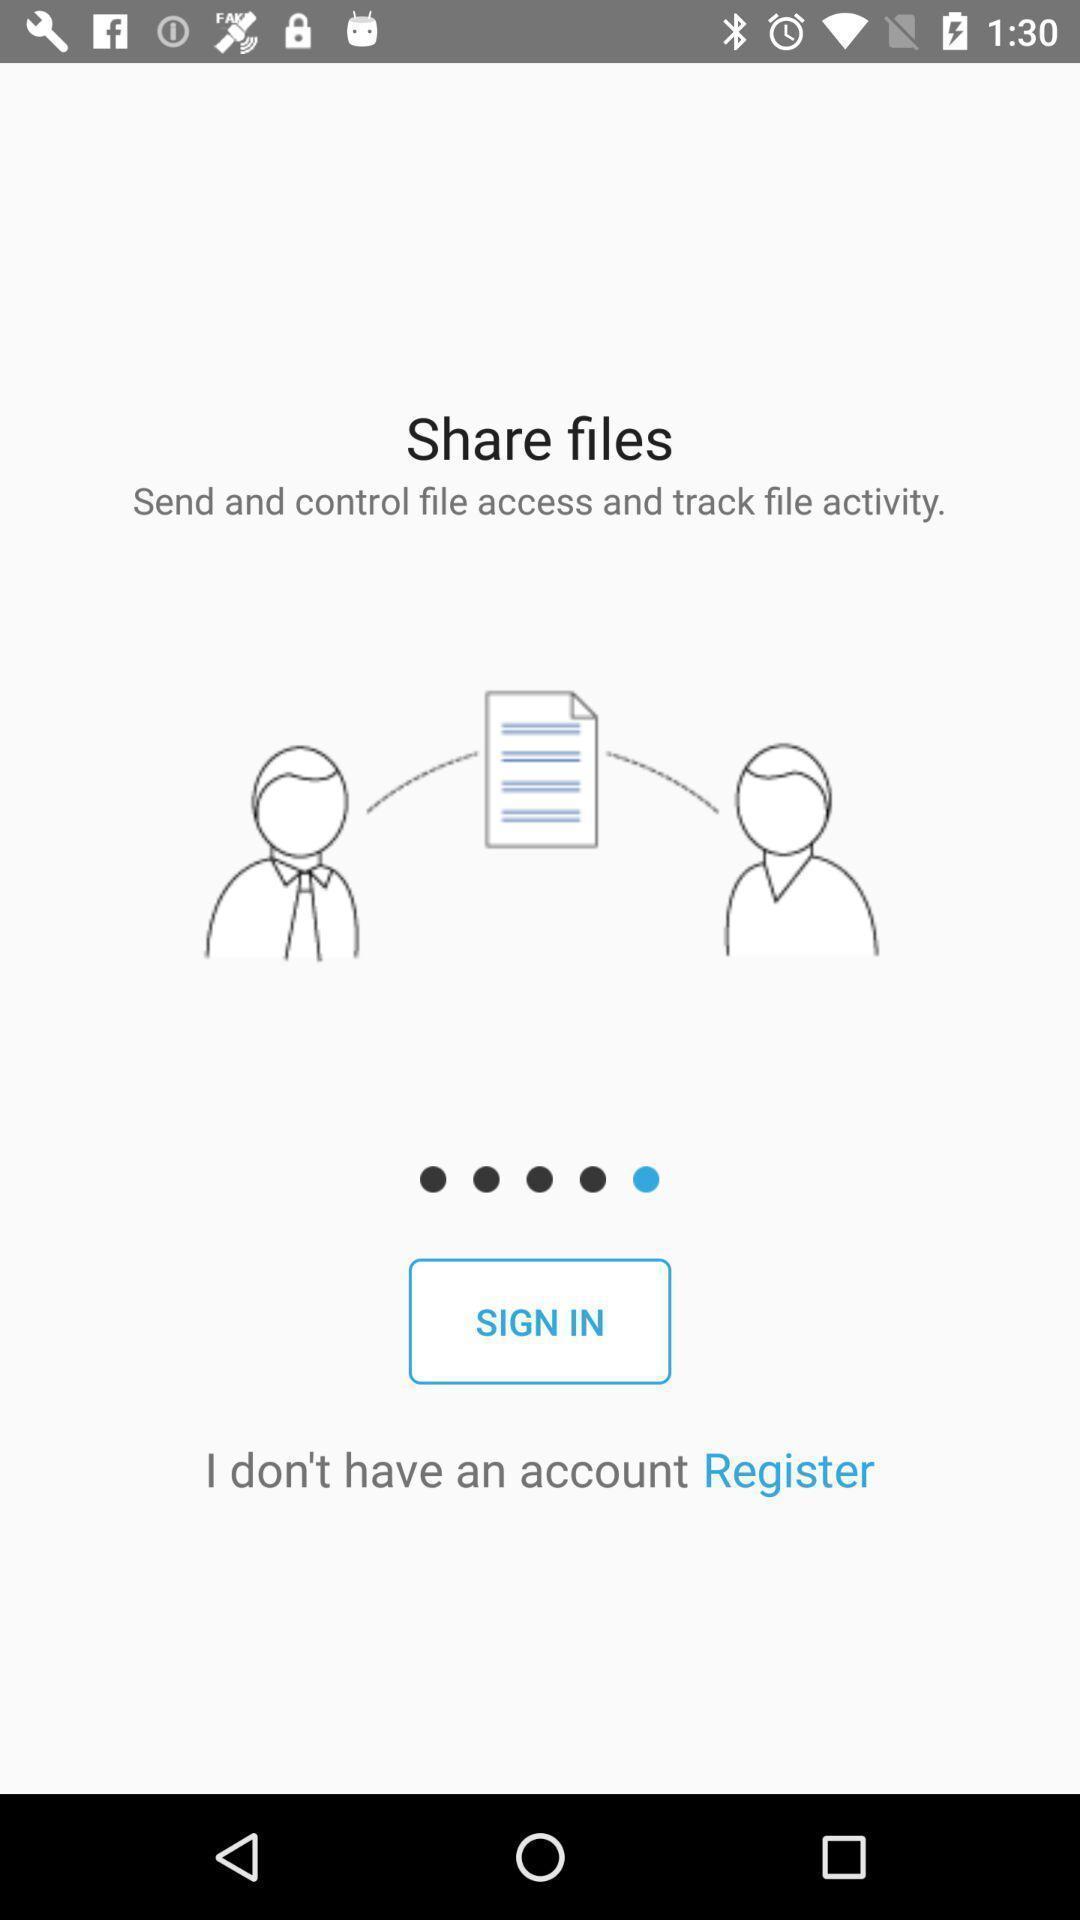What is the overall content of this screenshot? Sign in page for the application. 